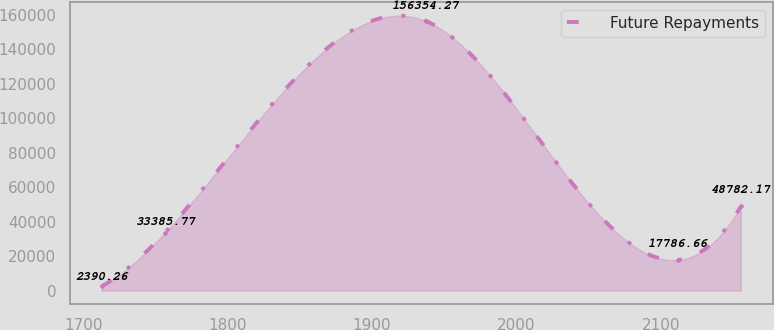Convert chart to OTSL. <chart><loc_0><loc_0><loc_500><loc_500><line_chart><ecel><fcel>Future Repayments<nl><fcel>1712.67<fcel>2390.26<nl><fcel>1756.4<fcel>33385.8<nl><fcel>1937.25<fcel>156354<nl><fcel>2111.54<fcel>17786.7<nl><fcel>2155.27<fcel>48782.2<nl></chart> 